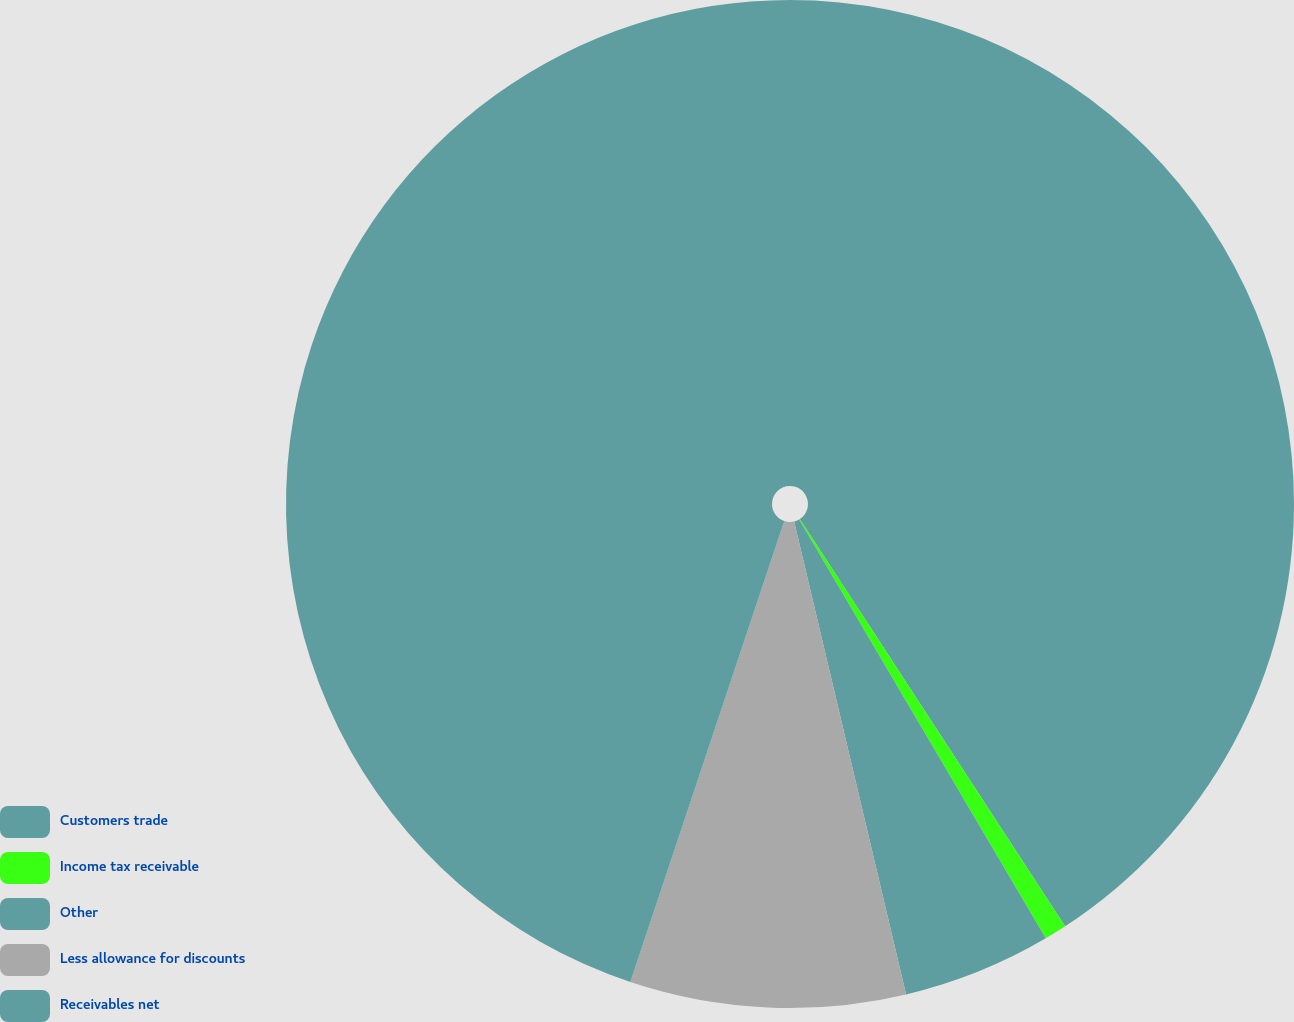Convert chart. <chart><loc_0><loc_0><loc_500><loc_500><pie_chart><fcel>Customers trade<fcel>Income tax receivable<fcel>Other<fcel>Less allowance for discounts<fcel>Receivables net<nl><fcel>40.81%<fcel>0.72%<fcel>4.77%<fcel>8.83%<fcel>44.87%<nl></chart> 